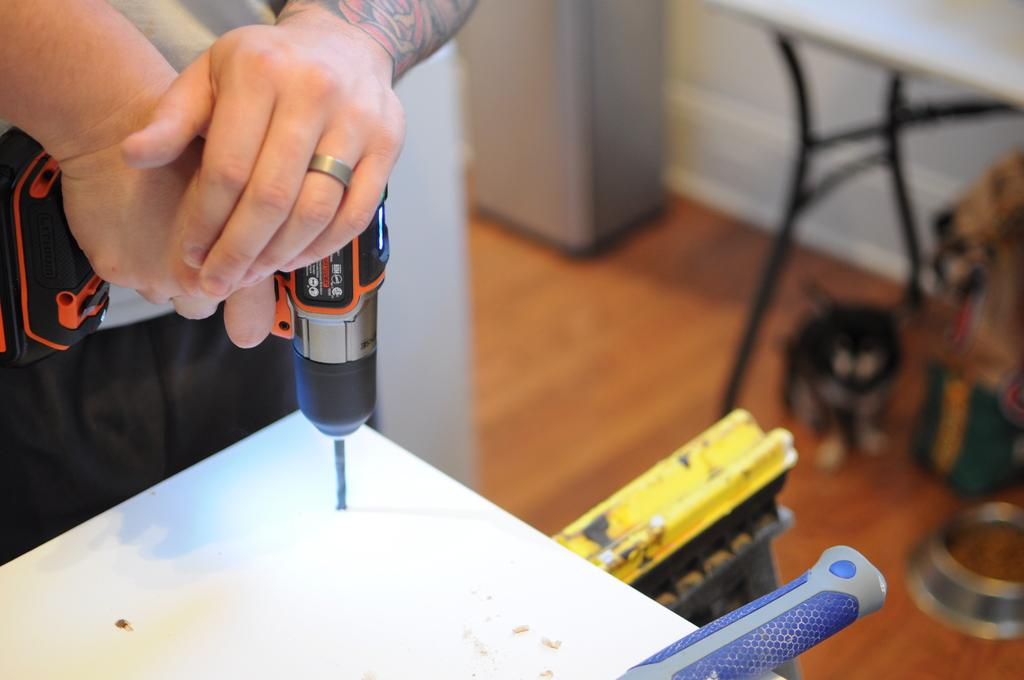Who or what is the main subject in the image? There is a person in the image. What is the person holding in the image? The person is holding a drilling machine. What type of surface is visible in the image? There is a floor in the image. What other furniture or objects can be seen in the image? There is a table in the image. What architectural feature is present in the image? There is a wall in the image. What type of quilt is being used to cover the chicken in the image? There is no quilt or chicken present in the image. What type of carpenter is shown working on the wall in the image? There is no carpenter present in the image; only a person holding a drilling machine is visible. 